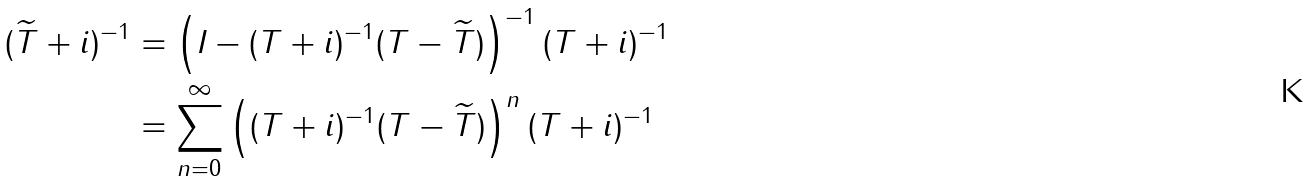<formula> <loc_0><loc_0><loc_500><loc_500>( \widetilde { T } + i ) ^ { - 1 } & = \left ( I - ( T + i ) ^ { - 1 } ( T - \widetilde { T } ) \right ) ^ { - 1 } ( T + i ) ^ { - 1 } \\ & = \sum _ { n = 0 } ^ { \infty } \left ( ( T + i ) ^ { - 1 } ( T - \widetilde { T } ) \right ) ^ { n } ( T + i ) ^ { - 1 }</formula> 